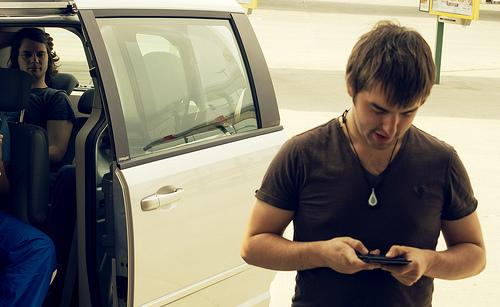Consider the quality of the image and describe any visible flaws or inconsistencies. The image quality is good, but there are overlapping bounding boxes that make it difficult to discern individual objects and their relative positions clearly. If the image was to be captioned, how would you summarize the image in one sentence? A man texting on a cell phone near an open sliding door of a van, wearing a necklace and a brown shirt. Identify and describe the main object of interest and any interactions it has with other objects. The main object is the man near the van, interacting with his cell phone, and wearing a necklace with a teardrop-shaped pendant. Analyze the overall sentiment portrayed in the image. The sentiment conveyed in the image is casual and focused, as a man uses his cell phone while standing next to an open door of a van. Infer the relationship between the man using the cell phone and the van in the image. The man using the cell phone might be the owner or driver of the van, waiting or taking a break next to an open sliding door. Provide a detailed description of what the man in the image is doing. The man in the image is using his cell phone while standing next to an open sliding van door, wearing a brown short sleeve shirt and a necklace with a pendant. While observing the image, identify and describe any notable or unique features about objects or people. Some unique features include the teardrop-shaped pendant on the man's necklace and the distinct colors on the yellow and green sign on the green support pole. What is the central focus of the image and the activity taking place? The central focus of the image is a man standing near an open sliding door of a van and pressing buttons on his cell phone. Count the different objects and people present in the scene. There are several objects in the scene: one man, one van with an open sliding door and handle, one person in the backseat, and various signs and poles. Analyze the image and determine a possible intent or purpose behind capturing it. The image might be captured to showcase everyday life, highlighting a moment when a man interacts with his cell phone while standing next to his van. 